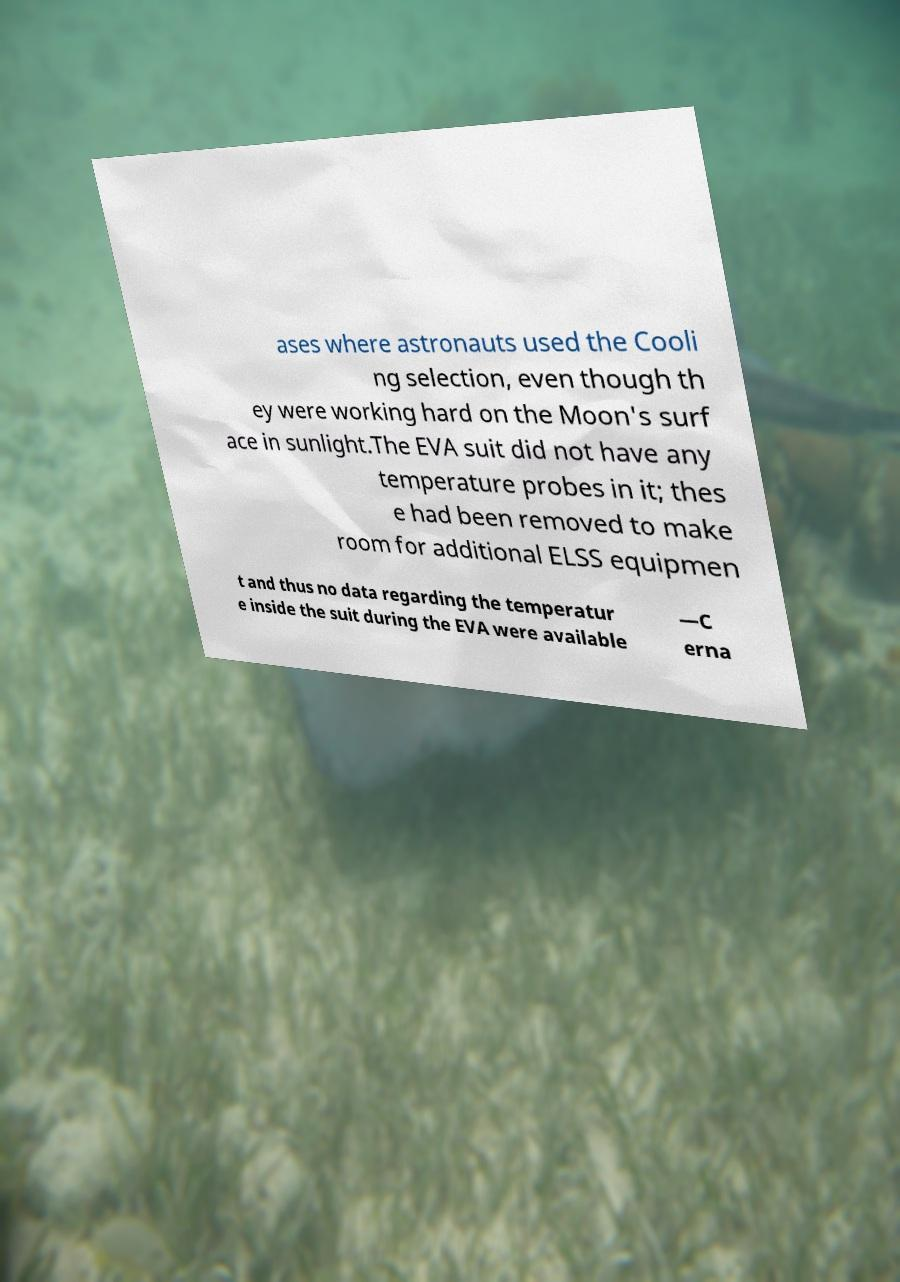I need the written content from this picture converted into text. Can you do that? ases where astronauts used the Cooli ng selection, even though th ey were working hard on the Moon's surf ace in sunlight.The EVA suit did not have any temperature probes in it; thes e had been removed to make room for additional ELSS equipmen t and thus no data regarding the temperatur e inside the suit during the EVA were available —C erna 